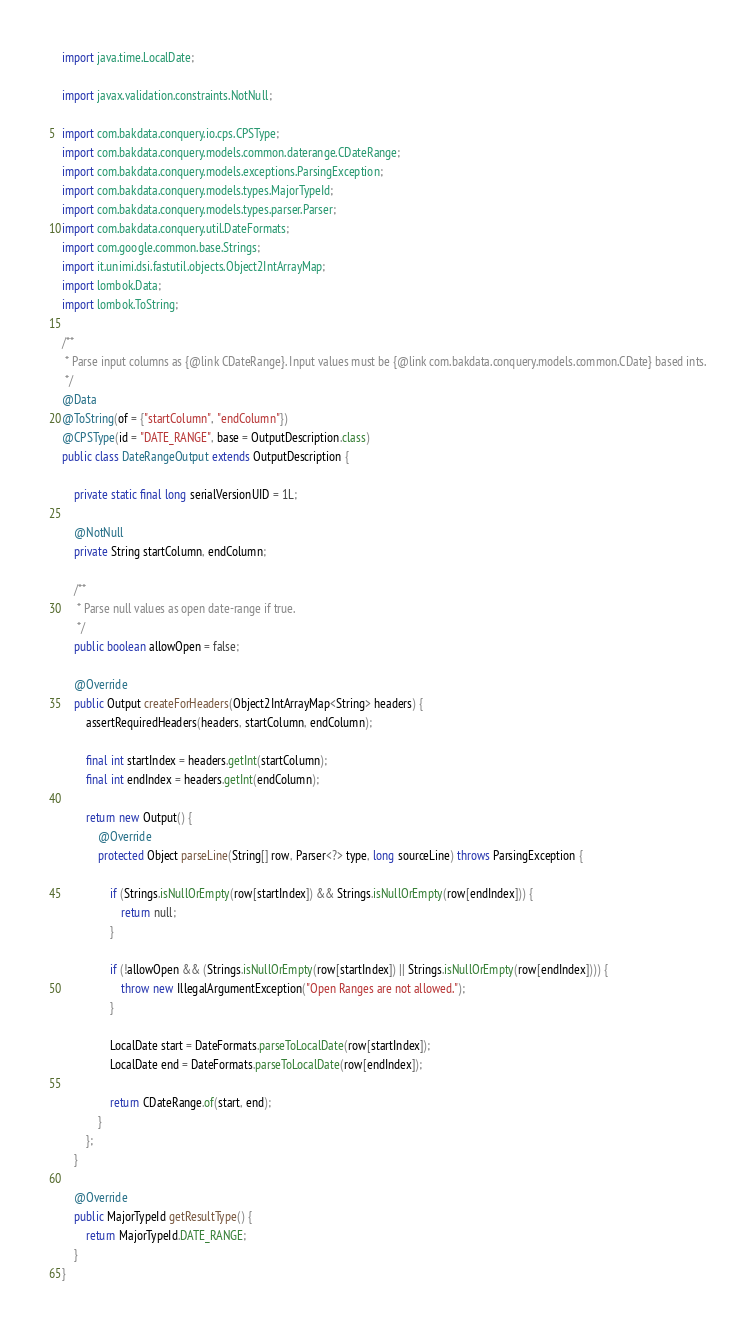<code> <loc_0><loc_0><loc_500><loc_500><_Java_>import java.time.LocalDate;

import javax.validation.constraints.NotNull;

import com.bakdata.conquery.io.cps.CPSType;
import com.bakdata.conquery.models.common.daterange.CDateRange;
import com.bakdata.conquery.models.exceptions.ParsingException;
import com.bakdata.conquery.models.types.MajorTypeId;
import com.bakdata.conquery.models.types.parser.Parser;
import com.bakdata.conquery.util.DateFormats;
import com.google.common.base.Strings;
import it.unimi.dsi.fastutil.objects.Object2IntArrayMap;
import lombok.Data;
import lombok.ToString;

/**
 * Parse input columns as {@link CDateRange}. Input values must be {@link com.bakdata.conquery.models.common.CDate} based ints.
 */
@Data
@ToString(of = {"startColumn", "endColumn"})
@CPSType(id = "DATE_RANGE", base = OutputDescription.class)
public class DateRangeOutput extends OutputDescription {

	private static final long serialVersionUID = 1L;

	@NotNull
	private String startColumn, endColumn;

	/**
	 * Parse null values as open date-range if true.
	 */
	public boolean allowOpen = false;

	@Override
	public Output createForHeaders(Object2IntArrayMap<String> headers) {
		assertRequiredHeaders(headers, startColumn, endColumn);

		final int startIndex = headers.getInt(startColumn);
		final int endIndex = headers.getInt(endColumn);

		return new Output() {
			@Override
			protected Object parseLine(String[] row, Parser<?> type, long sourceLine) throws ParsingException {

				if (Strings.isNullOrEmpty(row[startIndex]) && Strings.isNullOrEmpty(row[endIndex])) {
					return null;
				}

				if (!allowOpen && (Strings.isNullOrEmpty(row[startIndex]) || Strings.isNullOrEmpty(row[endIndex]))) {
					throw new IllegalArgumentException("Open Ranges are not allowed.");
				}

				LocalDate start = DateFormats.parseToLocalDate(row[startIndex]);
				LocalDate end = DateFormats.parseToLocalDate(row[endIndex]);

				return CDateRange.of(start, end);
			}
		};
	}

	@Override
	public MajorTypeId getResultType() {
		return MajorTypeId.DATE_RANGE;
	}
}</code> 